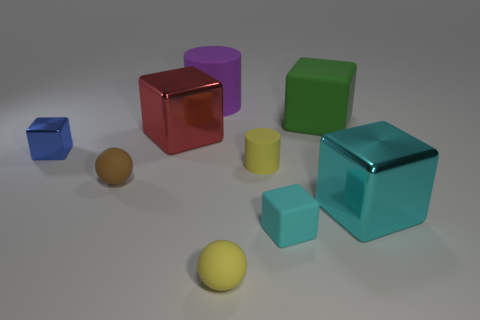How many things are tiny matte things that are on the right side of the red block or tiny yellow rubber cubes?
Your answer should be very brief. 3. How big is the metal cube that is in front of the small brown ball?
Your answer should be compact. Large. Are there fewer tiny blue things than small rubber balls?
Your answer should be compact. Yes. Do the big block that is left of the tiny yellow rubber cylinder and the yellow object that is in front of the tiny brown thing have the same material?
Provide a short and direct response. No. There is a large metallic object that is behind the metal cube in front of the tiny brown rubber thing to the left of the yellow rubber ball; what is its shape?
Keep it short and to the point. Cube. What number of other spheres have the same material as the yellow sphere?
Your response must be concise. 1. There is a large thing in front of the blue shiny object; what number of small matte things are in front of it?
Offer a terse response. 2. There is a tiny block that is in front of the small yellow rubber cylinder; is it the same color as the metal object right of the red object?
Offer a very short reply. Yes. There is a large object that is in front of the big green thing and on the left side of the tiny cyan rubber object; what shape is it?
Keep it short and to the point. Cube. Are there any large rubber objects that have the same shape as the small cyan thing?
Make the answer very short. Yes. 